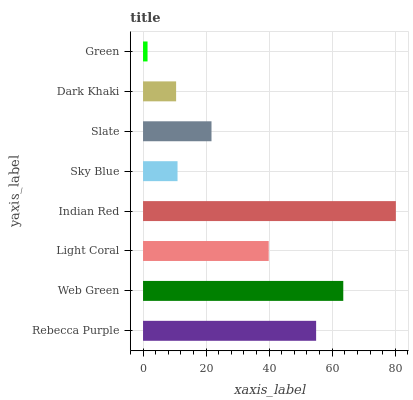Is Green the minimum?
Answer yes or no. Yes. Is Indian Red the maximum?
Answer yes or no. Yes. Is Web Green the minimum?
Answer yes or no. No. Is Web Green the maximum?
Answer yes or no. No. Is Web Green greater than Rebecca Purple?
Answer yes or no. Yes. Is Rebecca Purple less than Web Green?
Answer yes or no. Yes. Is Rebecca Purple greater than Web Green?
Answer yes or no. No. Is Web Green less than Rebecca Purple?
Answer yes or no. No. Is Light Coral the high median?
Answer yes or no. Yes. Is Slate the low median?
Answer yes or no. Yes. Is Sky Blue the high median?
Answer yes or no. No. Is Web Green the low median?
Answer yes or no. No. 